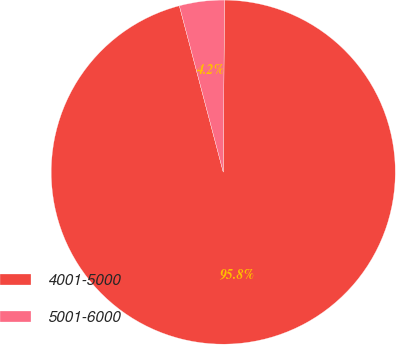Convert chart to OTSL. <chart><loc_0><loc_0><loc_500><loc_500><pie_chart><fcel>4001-5000<fcel>5001-6000<nl><fcel>95.78%<fcel>4.22%<nl></chart> 